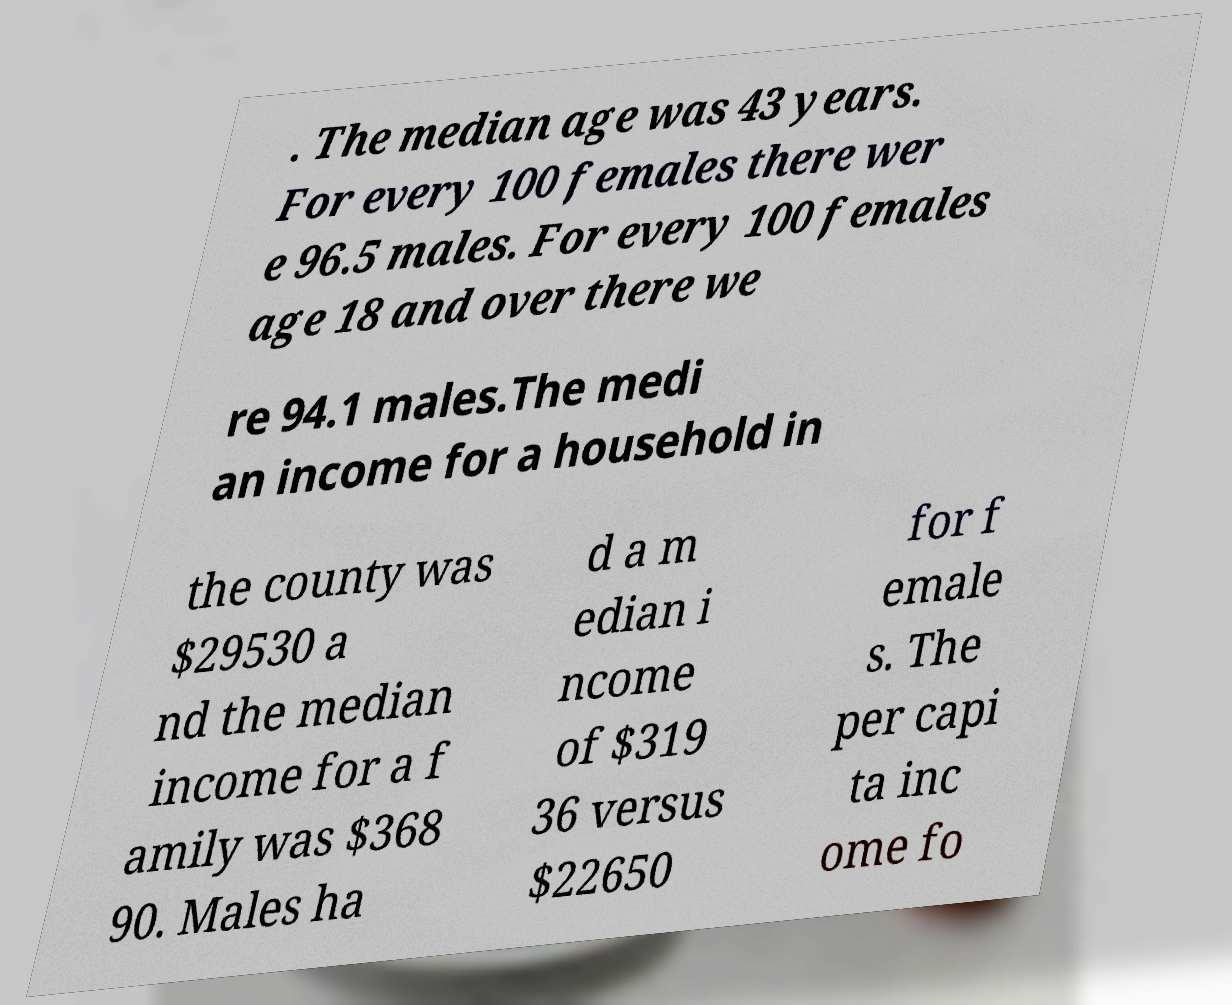For documentation purposes, I need the text within this image transcribed. Could you provide that? . The median age was 43 years. For every 100 females there wer e 96.5 males. For every 100 females age 18 and over there we re 94.1 males.The medi an income for a household in the county was $29530 a nd the median income for a f amily was $368 90. Males ha d a m edian i ncome of $319 36 versus $22650 for f emale s. The per capi ta inc ome fo 